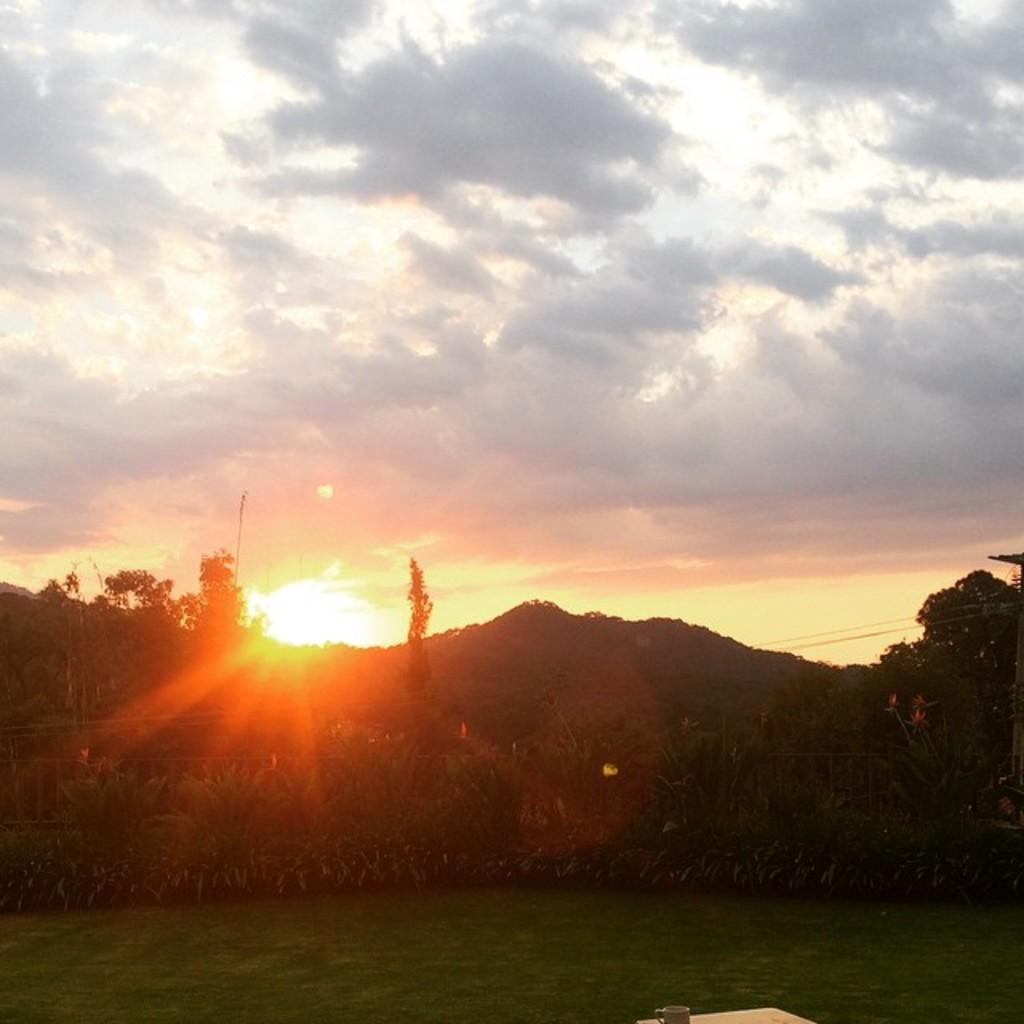What type of vegetation is present in the image? There is green grass in the image. What object is placed on the grass? There is a cup on the grass. What can be seen in the background of the image? There are plants and trees in the background of the image. What celestial body is visible in the image? The sun is visible in the image. What is the condition of the sky in the image? The sky is visible in the image and appears to be cloudy. Where is the nail located in the image? There is no nail present in the image. What type of cellar can be seen in the image? There is no cellar present in the image. 